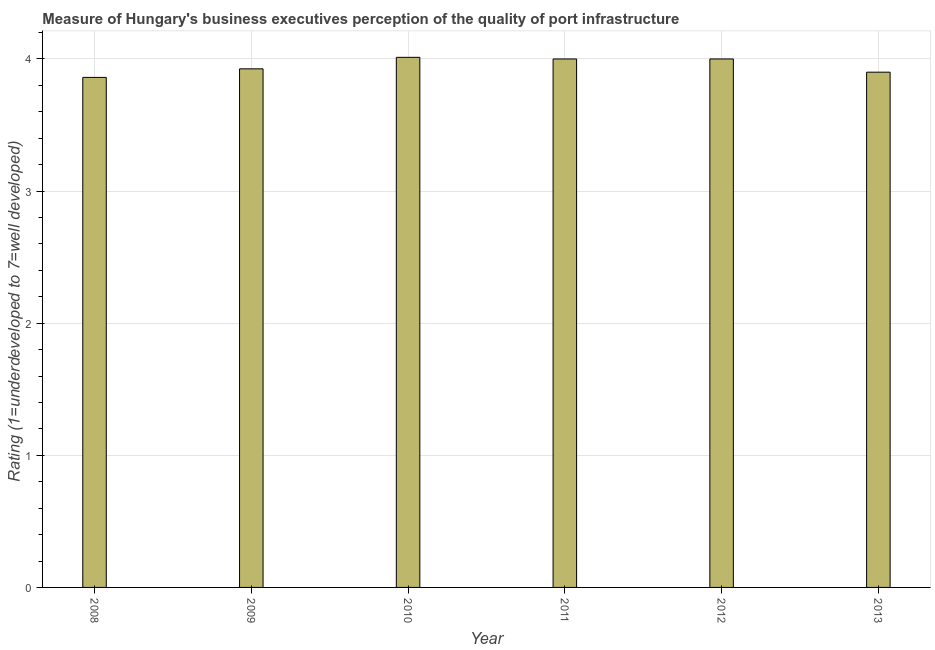What is the title of the graph?
Offer a terse response. Measure of Hungary's business executives perception of the quality of port infrastructure. What is the label or title of the X-axis?
Offer a very short reply. Year. What is the label or title of the Y-axis?
Ensure brevity in your answer.  Rating (1=underdeveloped to 7=well developed) . Across all years, what is the maximum rating measuring quality of port infrastructure?
Offer a terse response. 4.01. Across all years, what is the minimum rating measuring quality of port infrastructure?
Make the answer very short. 3.86. In which year was the rating measuring quality of port infrastructure maximum?
Provide a short and direct response. 2010. What is the sum of the rating measuring quality of port infrastructure?
Provide a short and direct response. 23.7. What is the difference between the rating measuring quality of port infrastructure in 2008 and 2013?
Provide a succinct answer. -0.04. What is the average rating measuring quality of port infrastructure per year?
Provide a succinct answer. 3.95. What is the median rating measuring quality of port infrastructure?
Your answer should be compact. 3.96. In how many years, is the rating measuring quality of port infrastructure greater than 3.6 ?
Your answer should be compact. 6. Is the rating measuring quality of port infrastructure in 2009 less than that in 2013?
Your answer should be compact. No. What is the difference between the highest and the second highest rating measuring quality of port infrastructure?
Your answer should be compact. 0.01. Is the sum of the rating measuring quality of port infrastructure in 2009 and 2011 greater than the maximum rating measuring quality of port infrastructure across all years?
Your response must be concise. Yes. What is the difference between the highest and the lowest rating measuring quality of port infrastructure?
Your response must be concise. 0.15. Are all the bars in the graph horizontal?
Your answer should be very brief. No. How many years are there in the graph?
Give a very brief answer. 6. What is the Rating (1=underdeveloped to 7=well developed)  of 2008?
Ensure brevity in your answer.  3.86. What is the Rating (1=underdeveloped to 7=well developed)  in 2009?
Ensure brevity in your answer.  3.93. What is the Rating (1=underdeveloped to 7=well developed)  of 2010?
Offer a very short reply. 4.01. What is the difference between the Rating (1=underdeveloped to 7=well developed)  in 2008 and 2009?
Offer a terse response. -0.06. What is the difference between the Rating (1=underdeveloped to 7=well developed)  in 2008 and 2010?
Your answer should be very brief. -0.15. What is the difference between the Rating (1=underdeveloped to 7=well developed)  in 2008 and 2011?
Your response must be concise. -0.14. What is the difference between the Rating (1=underdeveloped to 7=well developed)  in 2008 and 2012?
Your response must be concise. -0.14. What is the difference between the Rating (1=underdeveloped to 7=well developed)  in 2008 and 2013?
Offer a terse response. -0.04. What is the difference between the Rating (1=underdeveloped to 7=well developed)  in 2009 and 2010?
Offer a terse response. -0.09. What is the difference between the Rating (1=underdeveloped to 7=well developed)  in 2009 and 2011?
Your answer should be compact. -0.07. What is the difference between the Rating (1=underdeveloped to 7=well developed)  in 2009 and 2012?
Provide a short and direct response. -0.07. What is the difference between the Rating (1=underdeveloped to 7=well developed)  in 2009 and 2013?
Keep it short and to the point. 0.03. What is the difference between the Rating (1=underdeveloped to 7=well developed)  in 2010 and 2011?
Keep it short and to the point. 0.01. What is the difference between the Rating (1=underdeveloped to 7=well developed)  in 2010 and 2012?
Your response must be concise. 0.01. What is the difference between the Rating (1=underdeveloped to 7=well developed)  in 2010 and 2013?
Your response must be concise. 0.11. What is the difference between the Rating (1=underdeveloped to 7=well developed)  in 2011 and 2012?
Provide a short and direct response. 0. What is the ratio of the Rating (1=underdeveloped to 7=well developed)  in 2008 to that in 2012?
Offer a terse response. 0.96. What is the ratio of the Rating (1=underdeveloped to 7=well developed)  in 2009 to that in 2010?
Offer a terse response. 0.98. What is the ratio of the Rating (1=underdeveloped to 7=well developed)  in 2009 to that in 2013?
Offer a terse response. 1.01. What is the ratio of the Rating (1=underdeveloped to 7=well developed)  in 2010 to that in 2011?
Offer a terse response. 1. What is the ratio of the Rating (1=underdeveloped to 7=well developed)  in 2012 to that in 2013?
Give a very brief answer. 1.03. 